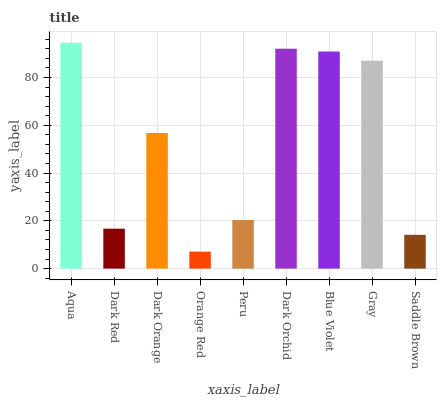Is Dark Red the minimum?
Answer yes or no. No. Is Dark Red the maximum?
Answer yes or no. No. Is Aqua greater than Dark Red?
Answer yes or no. Yes. Is Dark Red less than Aqua?
Answer yes or no. Yes. Is Dark Red greater than Aqua?
Answer yes or no. No. Is Aqua less than Dark Red?
Answer yes or no. No. Is Dark Orange the high median?
Answer yes or no. Yes. Is Dark Orange the low median?
Answer yes or no. Yes. Is Dark Orchid the high median?
Answer yes or no. No. Is Orange Red the low median?
Answer yes or no. No. 